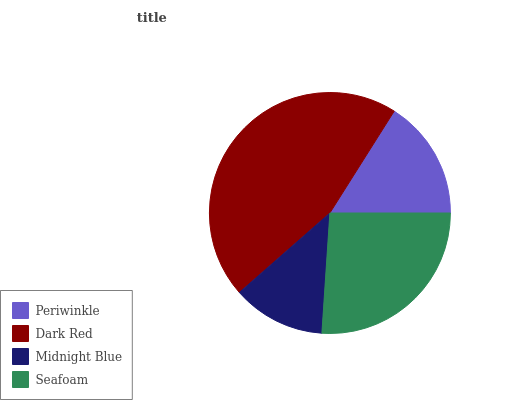Is Midnight Blue the minimum?
Answer yes or no. Yes. Is Dark Red the maximum?
Answer yes or no. Yes. Is Dark Red the minimum?
Answer yes or no. No. Is Midnight Blue the maximum?
Answer yes or no. No. Is Dark Red greater than Midnight Blue?
Answer yes or no. Yes. Is Midnight Blue less than Dark Red?
Answer yes or no. Yes. Is Midnight Blue greater than Dark Red?
Answer yes or no. No. Is Dark Red less than Midnight Blue?
Answer yes or no. No. Is Seafoam the high median?
Answer yes or no. Yes. Is Periwinkle the low median?
Answer yes or no. Yes. Is Periwinkle the high median?
Answer yes or no. No. Is Midnight Blue the low median?
Answer yes or no. No. 